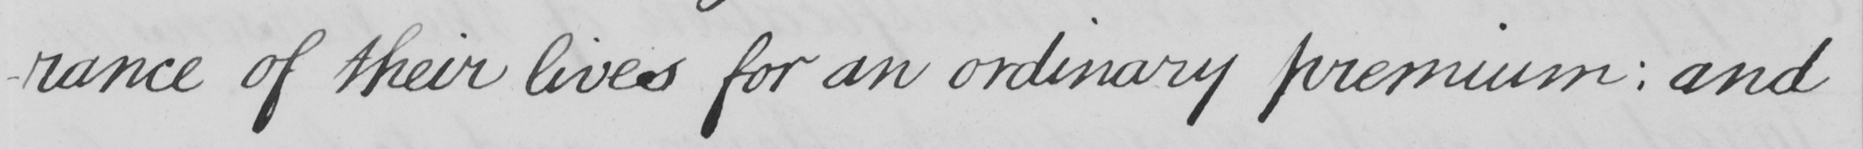What text is written in this handwritten line? -rance of their lives for an ordinary premium :  and 